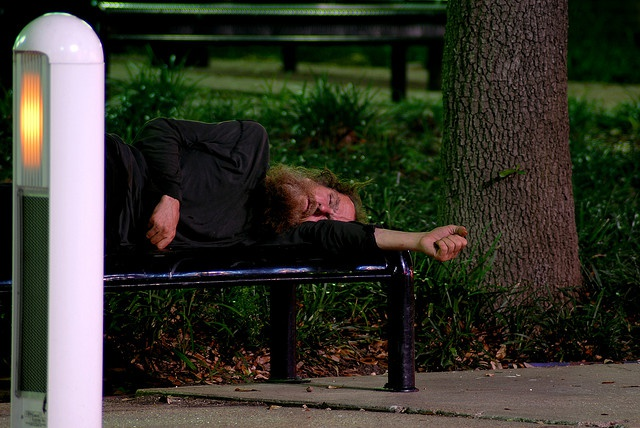Describe the objects in this image and their specific colors. I can see people in black, brown, and maroon tones and bench in black, navy, gray, and maroon tones in this image. 